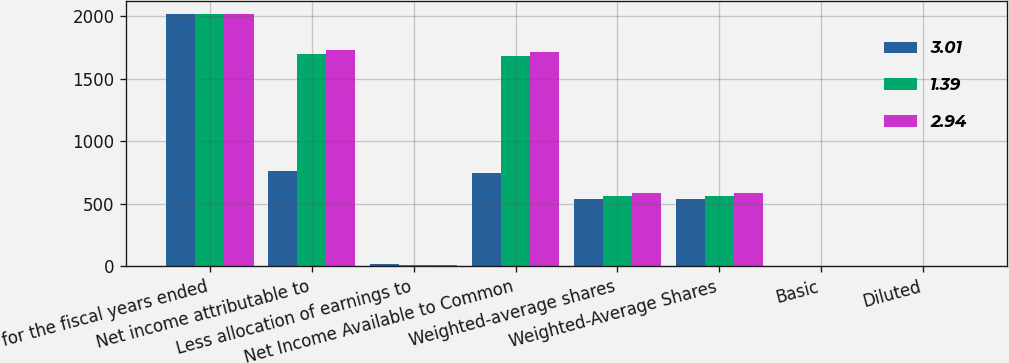Convert chart. <chart><loc_0><loc_0><loc_500><loc_500><stacked_bar_chart><ecel><fcel>for the fiscal years ended<fcel>Net income attributable to<fcel>Less allocation of earnings to<fcel>Net Income Available to Common<fcel>Weighted-average shares<fcel>Weighted-Average Shares<fcel>Basic<fcel>Diluted<nl><fcel>3.01<fcel>2018<fcel>764.4<fcel>17.6<fcel>746.8<fcel>537.4<fcel>538<fcel>1.39<fcel>1.39<nl><fcel>1.39<fcel>2017<fcel>1696.7<fcel>12.4<fcel>1684.3<fcel>558.8<fcel>559.1<fcel>3.01<fcel>3.01<nl><fcel>2.94<fcel>2016<fcel>1726.7<fcel>10.9<fcel>1715.8<fcel>583.8<fcel>583.8<fcel>2.94<fcel>2.94<nl></chart> 